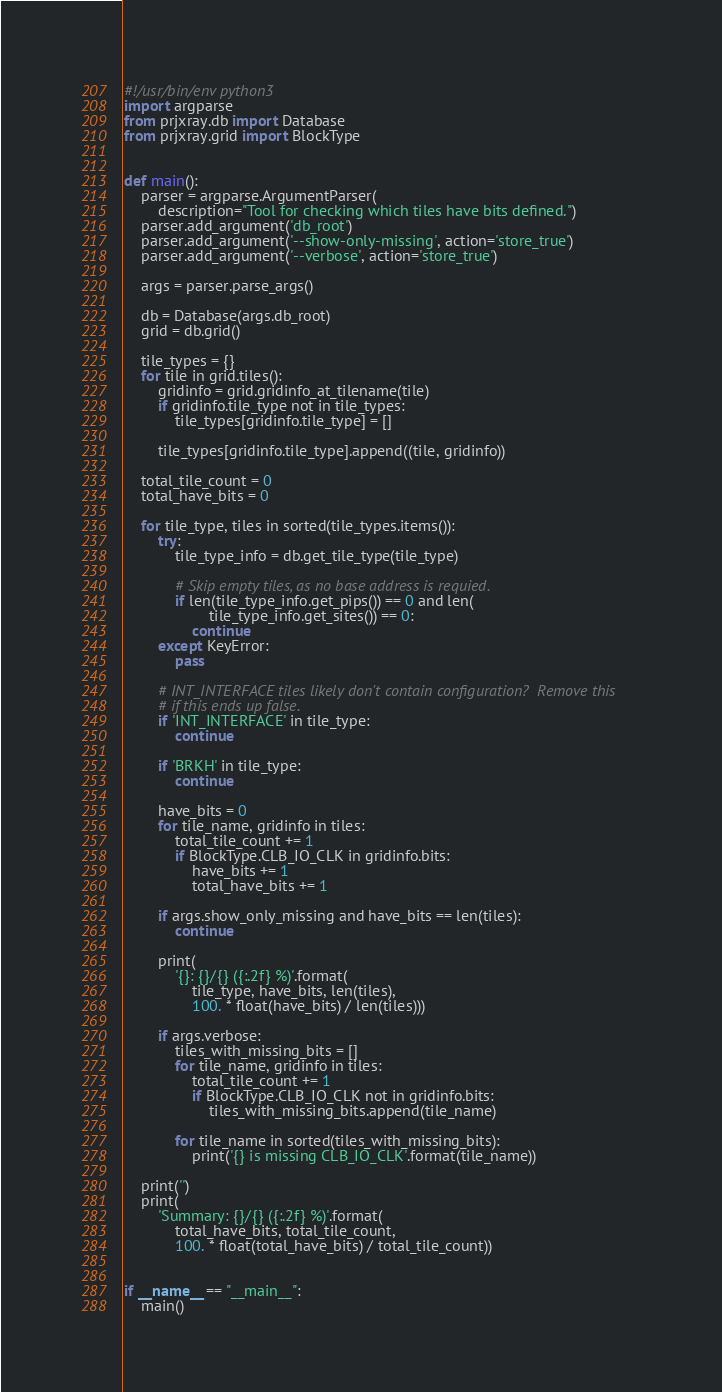<code> <loc_0><loc_0><loc_500><loc_500><_Python_>#!/usr/bin/env python3
import argparse
from prjxray.db import Database
from prjxray.grid import BlockType


def main():
    parser = argparse.ArgumentParser(
        description="Tool for checking which tiles have bits defined.")
    parser.add_argument('db_root')
    parser.add_argument('--show-only-missing', action='store_true')
    parser.add_argument('--verbose', action='store_true')

    args = parser.parse_args()

    db = Database(args.db_root)
    grid = db.grid()

    tile_types = {}
    for tile in grid.tiles():
        gridinfo = grid.gridinfo_at_tilename(tile)
        if gridinfo.tile_type not in tile_types:
            tile_types[gridinfo.tile_type] = []

        tile_types[gridinfo.tile_type].append((tile, gridinfo))

    total_tile_count = 0
    total_have_bits = 0

    for tile_type, tiles in sorted(tile_types.items()):
        try:
            tile_type_info = db.get_tile_type(tile_type)

            # Skip empty tiles, as no base address is requied.
            if len(tile_type_info.get_pips()) == 0 and len(
                    tile_type_info.get_sites()) == 0:
                continue
        except KeyError:
            pass

        # INT_INTERFACE tiles likely don't contain configuration?  Remove this
        # if this ends up false.
        if 'INT_INTERFACE' in tile_type:
            continue

        if 'BRKH' in tile_type:
            continue

        have_bits = 0
        for tile_name, gridinfo in tiles:
            total_tile_count += 1
            if BlockType.CLB_IO_CLK in gridinfo.bits:
                have_bits += 1
                total_have_bits += 1

        if args.show_only_missing and have_bits == len(tiles):
            continue

        print(
            '{}: {}/{} ({:.2f} %)'.format(
                tile_type, have_bits, len(tiles),
                100. * float(have_bits) / len(tiles)))

        if args.verbose:
            tiles_with_missing_bits = []
            for tile_name, gridinfo in tiles:
                total_tile_count += 1
                if BlockType.CLB_IO_CLK not in gridinfo.bits:
                    tiles_with_missing_bits.append(tile_name)

            for tile_name in sorted(tiles_with_missing_bits):
                print('{} is missing CLB_IO_CLK'.format(tile_name))

    print('')
    print(
        'Summary: {}/{} ({:.2f} %)'.format(
            total_have_bits, total_tile_count,
            100. * float(total_have_bits) / total_tile_count))


if __name__ == "__main__":
    main()
</code> 